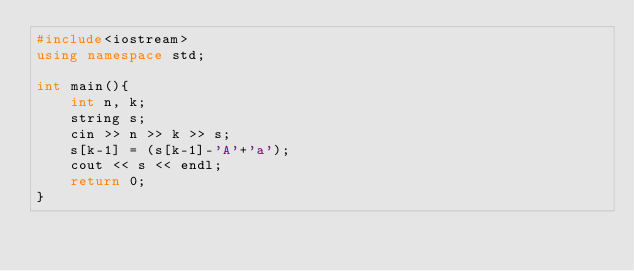Convert code to text. <code><loc_0><loc_0><loc_500><loc_500><_C++_>#include<iostream>
using namespace std;

int main(){
    int n, k;
    string s;
    cin >> n >> k >> s;
    s[k-1] = (s[k-1]-'A'+'a');
    cout << s << endl;
    return 0;
}</code> 